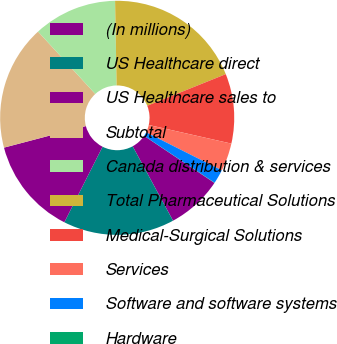<chart> <loc_0><loc_0><loc_500><loc_500><pie_chart><fcel>(In millions)<fcel>US Healthcare direct<fcel>US Healthcare sales to<fcel>Subtotal<fcel>Canada distribution & services<fcel>Total Pharmaceutical Solutions<fcel>Medical-Surgical Solutions<fcel>Services<fcel>Software and software systems<fcel>Hardware<nl><fcel>7.7%<fcel>15.37%<fcel>13.45%<fcel>17.28%<fcel>11.53%<fcel>19.2%<fcel>9.62%<fcel>3.87%<fcel>1.95%<fcel>0.03%<nl></chart> 